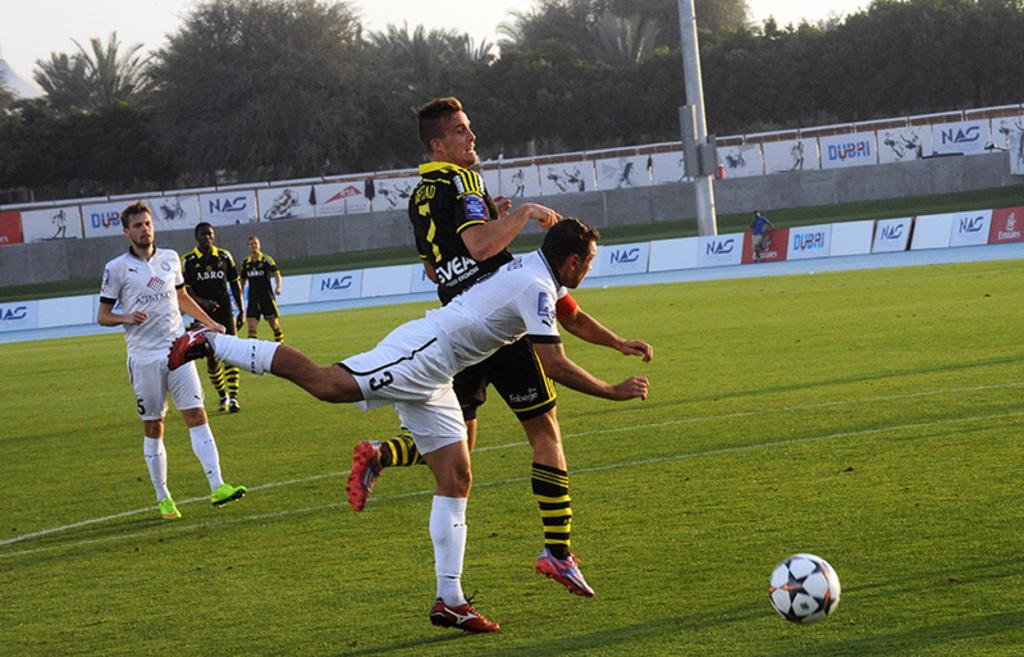What sport are the people playing in the image? The people are playing football in the image. Where is the football being played? The football is being played on the ground. What can be seen in the background of the image? There are trees visible in the background of the image. What type of brick is being used to build the creature in the image? There is no creature or brick present in the image; it features people playing football on the ground with trees in the background. 